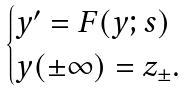Convert formula to latex. <formula><loc_0><loc_0><loc_500><loc_500>\begin{cases} y ^ { \prime } = F ( y ; s ) & \\ y ( \pm \infty ) = z _ { \pm } . & \end{cases}</formula> 